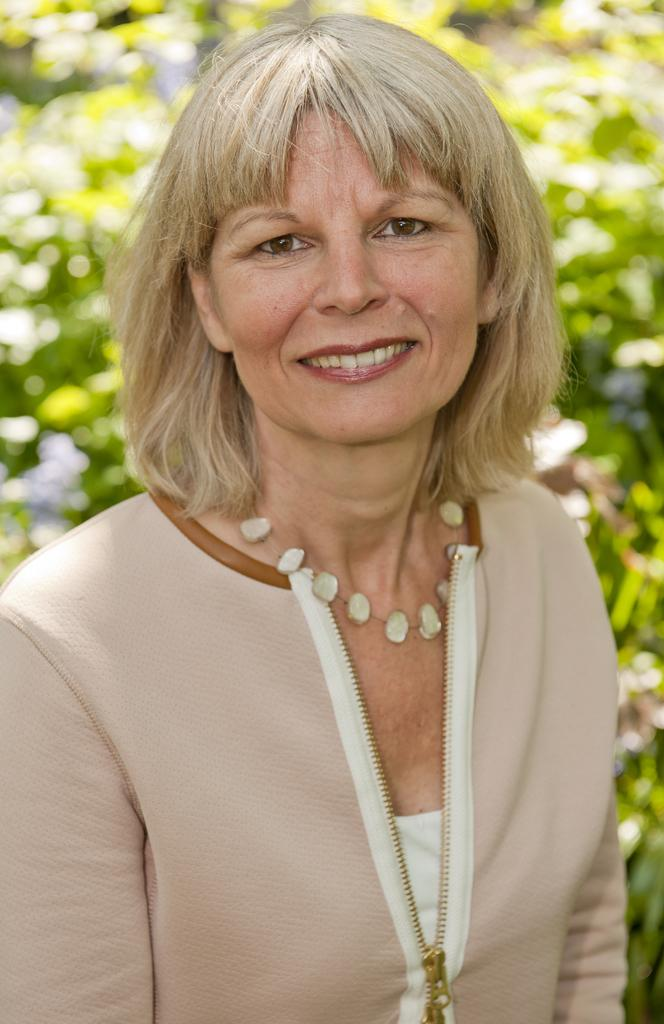What is the main subject of the image? There is a close-up picture of a woman in the image. What can be observed about the woman's attire? The woman is wearing clothes. Are there any accessories visible on the woman? Yes, the woman is wearing a neck chain. What is the woman's facial expression in the image? The woman is smiling. How is the background of the image depicted? The background of the image is slightly blurred. What type of lipstick is the woman wearing in the image? There is no mention of lipstick or any makeup in the provided facts, so it cannot be determined from the image. How many pies can be seen on the woman's face in the image? There are no pies present on the woman's face in the image. 